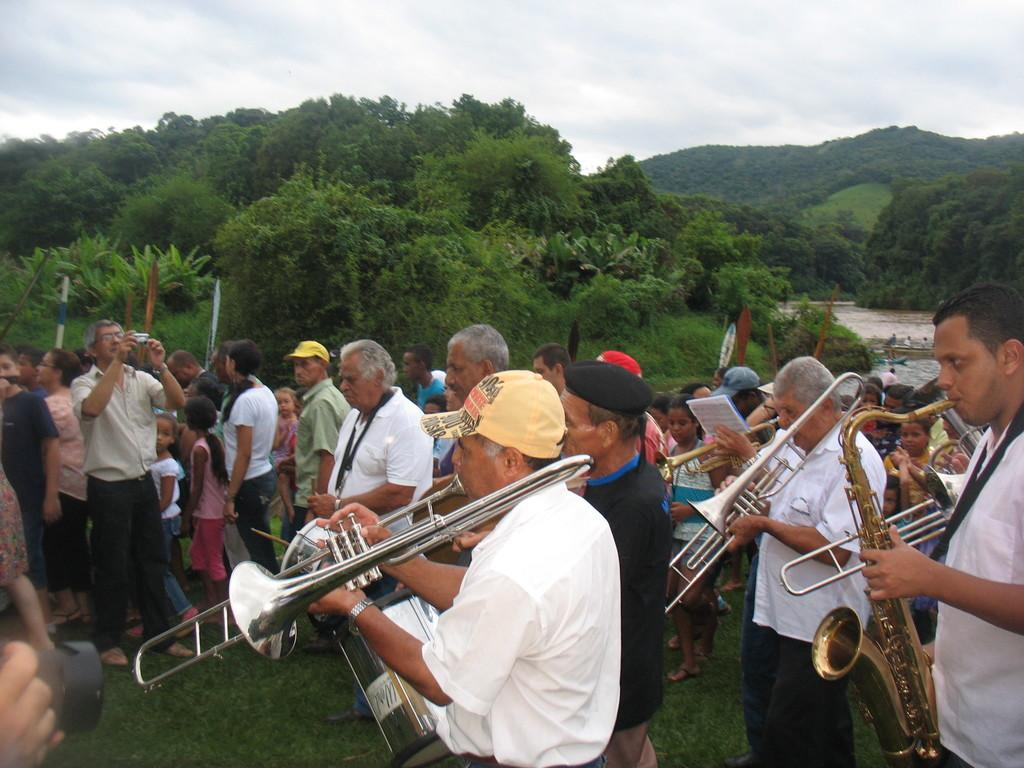What is the main subject of the image? The main subject of the image is a group of men. What are the men doing in the image? The men are playing saxophones in the image. Where are the men standing in the image? The men are standing on the ground in the image. What can be seen in the sky in the image? Clouds are present in the sky in the image. What type of plants can be seen growing on the men's tongues in the image? There are no plants visible on the men's tongues in the image, as the focus is on the men playing saxophones. 